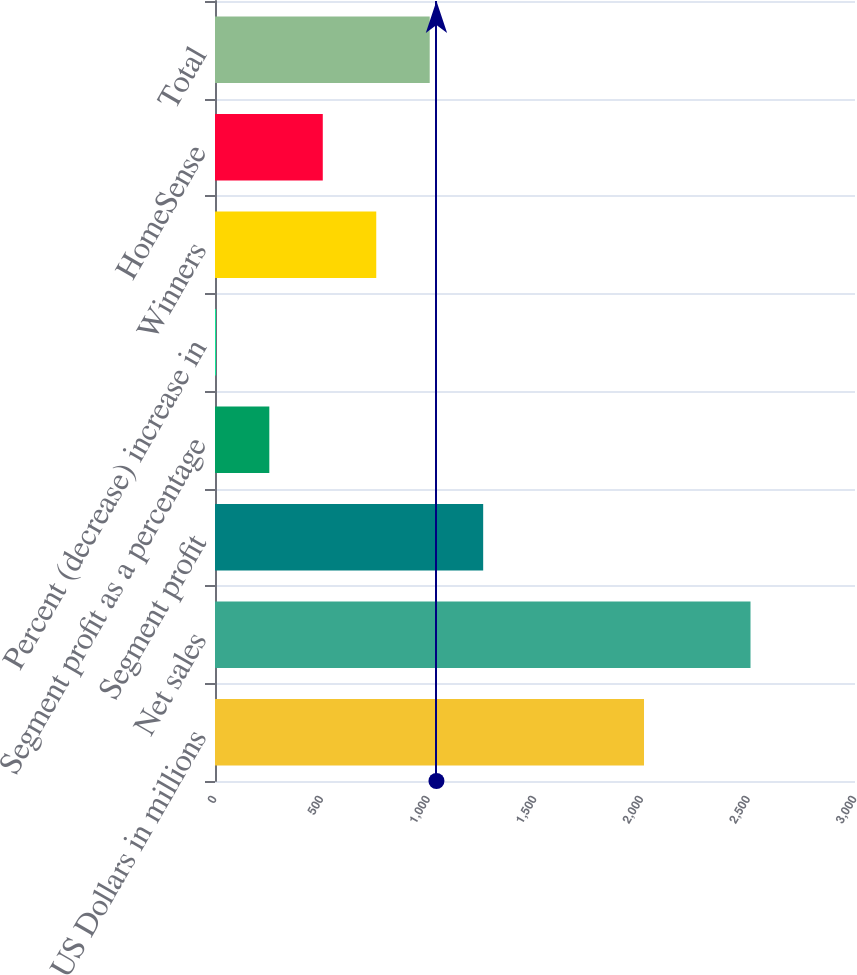Convert chart to OTSL. <chart><loc_0><loc_0><loc_500><loc_500><bar_chart><fcel>US Dollars in millions<fcel>Net sales<fcel>Segment profit<fcel>Segment profit as a percentage<fcel>Percent (decrease) increase in<fcel>Winners<fcel>HomeSense<fcel>Total<nl><fcel>2011<fcel>2510.2<fcel>1257.1<fcel>254.62<fcel>4<fcel>755.86<fcel>505.24<fcel>1006.48<nl></chart> 